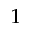<formula> <loc_0><loc_0><loc_500><loc_500>^ { 1 }</formula> 